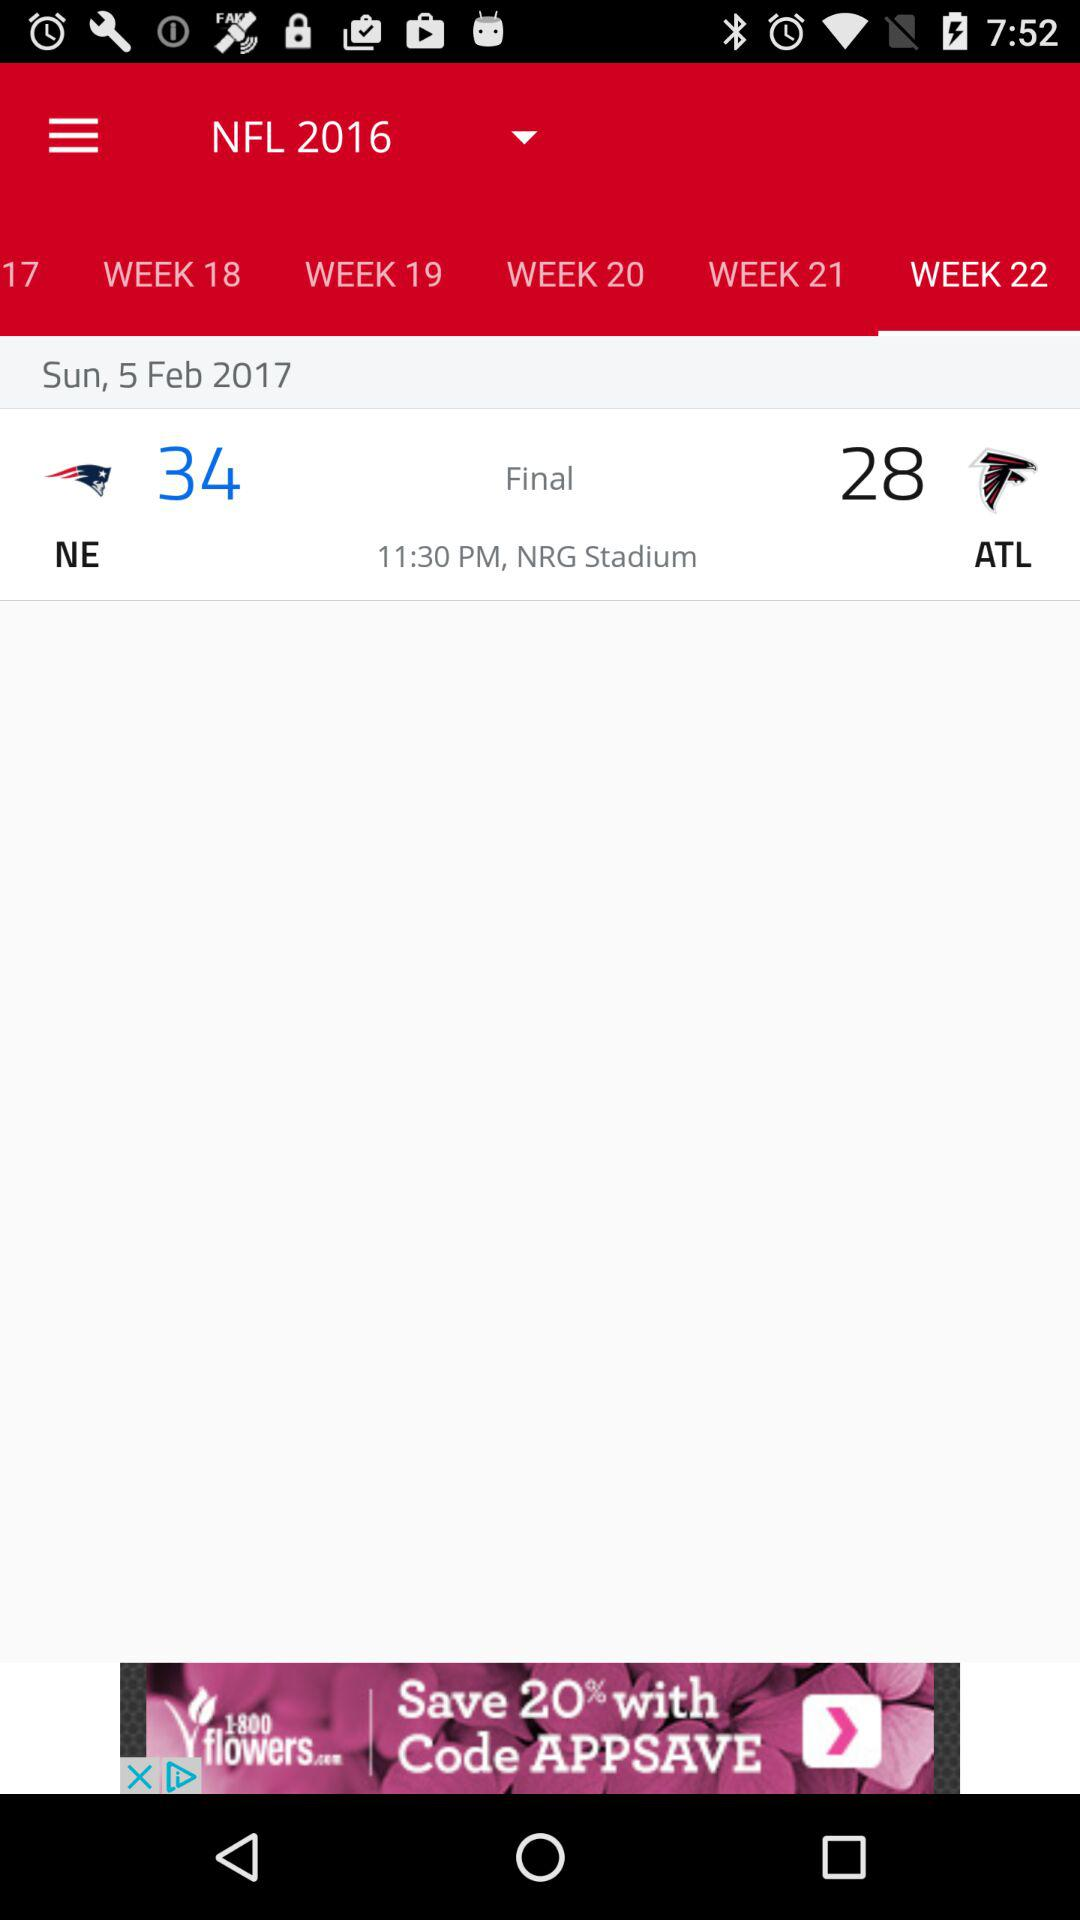What is the selected week? The selected week is 22. 